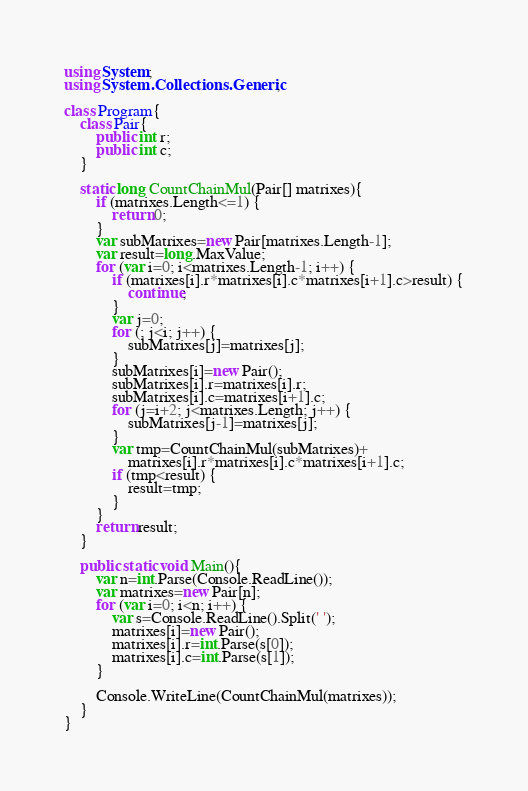Convert code to text. <code><loc_0><loc_0><loc_500><loc_500><_C#_>using System;
using System.Collections.Generic;

class Program{
    class Pair{
        public int r;
        public int c;
    }

    static long CountChainMul(Pair[] matrixes){
        if (matrixes.Length<=1) {
            return 0;
        }
        var subMatrixes=new Pair[matrixes.Length-1];
        var result=long.MaxValue;
        for (var i=0; i<matrixes.Length-1; i++) {
            if (matrixes[i].r*matrixes[i].c*matrixes[i+1].c>result) {
                continue;
            }
            var j=0;
            for (; j<i; j++) {
                subMatrixes[j]=matrixes[j];
            }
            subMatrixes[i]=new Pair();
            subMatrixes[i].r=matrixes[i].r;
            subMatrixes[i].c=matrixes[i+1].c;
            for (j=i+2; j<matrixes.Length; j++) {
                subMatrixes[j-1]=matrixes[j];
            }
            var tmp=CountChainMul(subMatrixes)+
                matrixes[i].r*matrixes[i].c*matrixes[i+1].c;
            if (tmp<result) {
                result=tmp;
            }
        }
        return result;
    }

    public static void Main(){
        var n=int.Parse(Console.ReadLine());
        var matrixes=new Pair[n];
        for (var i=0; i<n; i++) {
            var s=Console.ReadLine().Split(' ');
            matrixes[i]=new Pair();
            matrixes[i].r=int.Parse(s[0]);
            matrixes[i].c=int.Parse(s[1]);
        }

        Console.WriteLine(CountChainMul(matrixes));
    }
}</code> 